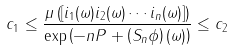<formula> <loc_0><loc_0><loc_500><loc_500>c _ { 1 } \leq \frac { \mu \left ( [ i _ { 1 } ( \omega ) i _ { 2 } ( \omega ) \cdots i _ { n } ( \omega ) ] \right ) } { \exp \left ( - n P + \left ( S _ { n } \phi \right ) ( \omega ) \right ) } \leq c _ { 2 }</formula> 